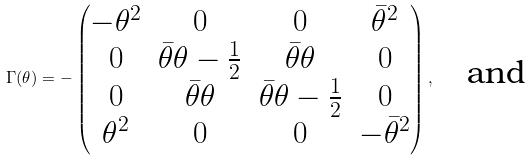<formula> <loc_0><loc_0><loc_500><loc_500>\Gamma ( \theta ) = - \begin{pmatrix} - \theta ^ { 2 } & 0 & 0 & \bar { \theta } ^ { 2 } \\ 0 & \bar { \theta } \theta - \frac { 1 } { 2 } & \bar { \theta } \theta & 0 \\ 0 & \bar { \theta } \theta & \bar { \theta } \theta - \frac { 1 } { 2 } & 0 \\ \theta ^ { 2 } & 0 & 0 & - \bar { \theta } ^ { 2 } \end{pmatrix} , \quad \text {and}</formula> 